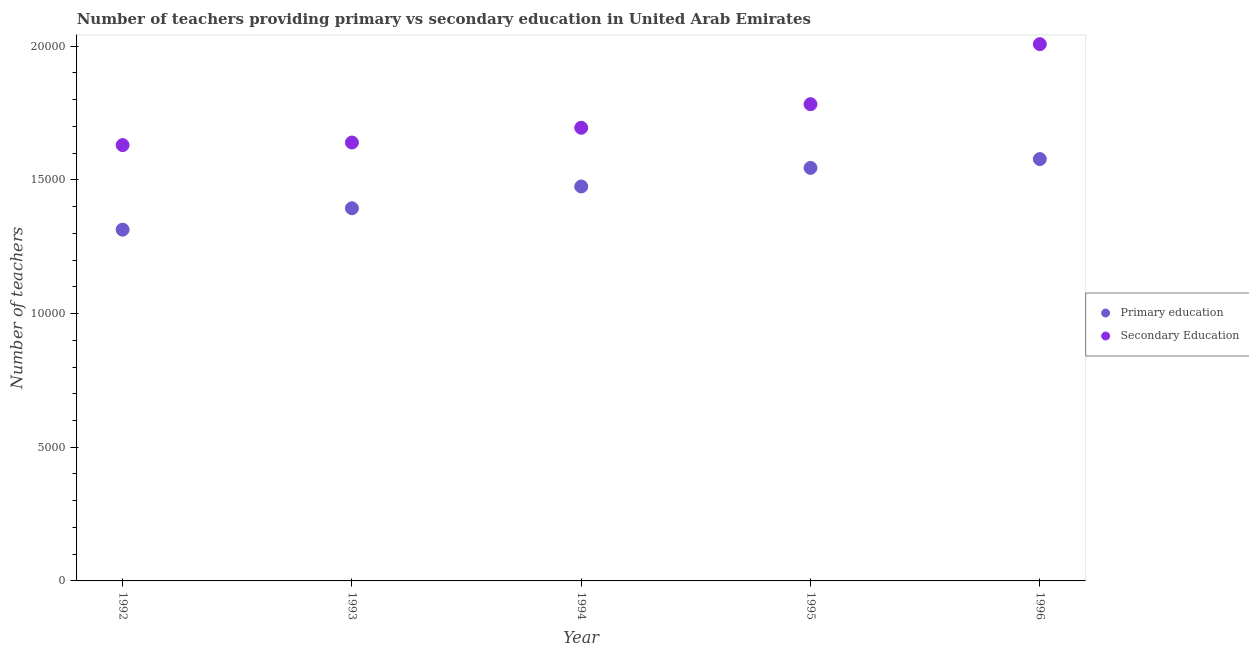What is the number of secondary teachers in 1994?
Your answer should be compact. 1.70e+04. Across all years, what is the maximum number of secondary teachers?
Offer a very short reply. 2.01e+04. Across all years, what is the minimum number of secondary teachers?
Ensure brevity in your answer.  1.63e+04. In which year was the number of primary teachers maximum?
Make the answer very short. 1996. In which year was the number of secondary teachers minimum?
Make the answer very short. 1992. What is the total number of secondary teachers in the graph?
Make the answer very short. 8.76e+04. What is the difference between the number of secondary teachers in 1994 and that in 1995?
Ensure brevity in your answer.  -882. What is the difference between the number of secondary teachers in 1996 and the number of primary teachers in 1995?
Your response must be concise. 4629. What is the average number of secondary teachers per year?
Your answer should be compact. 1.75e+04. In the year 1992, what is the difference between the number of primary teachers and number of secondary teachers?
Your answer should be compact. -3163. What is the ratio of the number of secondary teachers in 1992 to that in 1993?
Ensure brevity in your answer.  0.99. Is the difference between the number of secondary teachers in 1992 and 1996 greater than the difference between the number of primary teachers in 1992 and 1996?
Provide a succinct answer. No. What is the difference between the highest and the second highest number of primary teachers?
Your response must be concise. 330. What is the difference between the highest and the lowest number of secondary teachers?
Your response must be concise. 3776. Does the number of secondary teachers monotonically increase over the years?
Provide a succinct answer. Yes. How many dotlines are there?
Your response must be concise. 2. Does the graph contain any zero values?
Provide a short and direct response. No. Does the graph contain grids?
Ensure brevity in your answer.  No. Where does the legend appear in the graph?
Your answer should be very brief. Center right. How are the legend labels stacked?
Make the answer very short. Vertical. What is the title of the graph?
Provide a short and direct response. Number of teachers providing primary vs secondary education in United Arab Emirates. What is the label or title of the X-axis?
Offer a very short reply. Year. What is the label or title of the Y-axis?
Make the answer very short. Number of teachers. What is the Number of teachers of Primary education in 1992?
Your response must be concise. 1.31e+04. What is the Number of teachers of Secondary Education in 1992?
Provide a succinct answer. 1.63e+04. What is the Number of teachers in Primary education in 1993?
Ensure brevity in your answer.  1.39e+04. What is the Number of teachers of Secondary Education in 1993?
Keep it short and to the point. 1.64e+04. What is the Number of teachers of Primary education in 1994?
Your answer should be very brief. 1.48e+04. What is the Number of teachers of Secondary Education in 1994?
Give a very brief answer. 1.70e+04. What is the Number of teachers of Primary education in 1995?
Keep it short and to the point. 1.54e+04. What is the Number of teachers of Secondary Education in 1995?
Give a very brief answer. 1.78e+04. What is the Number of teachers in Primary education in 1996?
Give a very brief answer. 1.58e+04. What is the Number of teachers of Secondary Education in 1996?
Provide a succinct answer. 2.01e+04. Across all years, what is the maximum Number of teachers of Primary education?
Make the answer very short. 1.58e+04. Across all years, what is the maximum Number of teachers in Secondary Education?
Give a very brief answer. 2.01e+04. Across all years, what is the minimum Number of teachers of Primary education?
Provide a short and direct response. 1.31e+04. Across all years, what is the minimum Number of teachers in Secondary Education?
Ensure brevity in your answer.  1.63e+04. What is the total Number of teachers in Primary education in the graph?
Give a very brief answer. 7.31e+04. What is the total Number of teachers in Secondary Education in the graph?
Your answer should be very brief. 8.76e+04. What is the difference between the Number of teachers of Primary education in 1992 and that in 1993?
Make the answer very short. -801. What is the difference between the Number of teachers of Secondary Education in 1992 and that in 1993?
Your response must be concise. -97. What is the difference between the Number of teachers of Primary education in 1992 and that in 1994?
Offer a very short reply. -1615. What is the difference between the Number of teachers in Secondary Education in 1992 and that in 1994?
Make the answer very short. -648. What is the difference between the Number of teachers in Primary education in 1992 and that in 1995?
Offer a terse response. -2310. What is the difference between the Number of teachers in Secondary Education in 1992 and that in 1995?
Keep it short and to the point. -1530. What is the difference between the Number of teachers of Primary education in 1992 and that in 1996?
Give a very brief answer. -2640. What is the difference between the Number of teachers in Secondary Education in 1992 and that in 1996?
Give a very brief answer. -3776. What is the difference between the Number of teachers in Primary education in 1993 and that in 1994?
Your answer should be compact. -814. What is the difference between the Number of teachers in Secondary Education in 1993 and that in 1994?
Offer a terse response. -551. What is the difference between the Number of teachers of Primary education in 1993 and that in 1995?
Offer a terse response. -1509. What is the difference between the Number of teachers in Secondary Education in 1993 and that in 1995?
Your answer should be compact. -1433. What is the difference between the Number of teachers in Primary education in 1993 and that in 1996?
Provide a short and direct response. -1839. What is the difference between the Number of teachers in Secondary Education in 1993 and that in 1996?
Give a very brief answer. -3679. What is the difference between the Number of teachers of Primary education in 1994 and that in 1995?
Your answer should be very brief. -695. What is the difference between the Number of teachers in Secondary Education in 1994 and that in 1995?
Provide a short and direct response. -882. What is the difference between the Number of teachers in Primary education in 1994 and that in 1996?
Keep it short and to the point. -1025. What is the difference between the Number of teachers in Secondary Education in 1994 and that in 1996?
Your response must be concise. -3128. What is the difference between the Number of teachers of Primary education in 1995 and that in 1996?
Offer a very short reply. -330. What is the difference between the Number of teachers in Secondary Education in 1995 and that in 1996?
Provide a short and direct response. -2246. What is the difference between the Number of teachers in Primary education in 1992 and the Number of teachers in Secondary Education in 1993?
Provide a succinct answer. -3260. What is the difference between the Number of teachers of Primary education in 1992 and the Number of teachers of Secondary Education in 1994?
Give a very brief answer. -3811. What is the difference between the Number of teachers in Primary education in 1992 and the Number of teachers in Secondary Education in 1995?
Give a very brief answer. -4693. What is the difference between the Number of teachers in Primary education in 1992 and the Number of teachers in Secondary Education in 1996?
Provide a succinct answer. -6939. What is the difference between the Number of teachers in Primary education in 1993 and the Number of teachers in Secondary Education in 1994?
Provide a short and direct response. -3010. What is the difference between the Number of teachers in Primary education in 1993 and the Number of teachers in Secondary Education in 1995?
Your answer should be very brief. -3892. What is the difference between the Number of teachers in Primary education in 1993 and the Number of teachers in Secondary Education in 1996?
Provide a short and direct response. -6138. What is the difference between the Number of teachers of Primary education in 1994 and the Number of teachers of Secondary Education in 1995?
Provide a succinct answer. -3078. What is the difference between the Number of teachers of Primary education in 1994 and the Number of teachers of Secondary Education in 1996?
Offer a very short reply. -5324. What is the difference between the Number of teachers in Primary education in 1995 and the Number of teachers in Secondary Education in 1996?
Ensure brevity in your answer.  -4629. What is the average Number of teachers in Primary education per year?
Offer a very short reply. 1.46e+04. What is the average Number of teachers in Secondary Education per year?
Make the answer very short. 1.75e+04. In the year 1992, what is the difference between the Number of teachers of Primary education and Number of teachers of Secondary Education?
Your response must be concise. -3163. In the year 1993, what is the difference between the Number of teachers of Primary education and Number of teachers of Secondary Education?
Your response must be concise. -2459. In the year 1994, what is the difference between the Number of teachers of Primary education and Number of teachers of Secondary Education?
Your answer should be very brief. -2196. In the year 1995, what is the difference between the Number of teachers in Primary education and Number of teachers in Secondary Education?
Make the answer very short. -2383. In the year 1996, what is the difference between the Number of teachers of Primary education and Number of teachers of Secondary Education?
Your answer should be compact. -4299. What is the ratio of the Number of teachers in Primary education in 1992 to that in 1993?
Keep it short and to the point. 0.94. What is the ratio of the Number of teachers of Secondary Education in 1992 to that in 1993?
Your answer should be very brief. 0.99. What is the ratio of the Number of teachers in Primary education in 1992 to that in 1994?
Your response must be concise. 0.89. What is the ratio of the Number of teachers of Secondary Education in 1992 to that in 1994?
Keep it short and to the point. 0.96. What is the ratio of the Number of teachers in Primary education in 1992 to that in 1995?
Make the answer very short. 0.85. What is the ratio of the Number of teachers of Secondary Education in 1992 to that in 1995?
Give a very brief answer. 0.91. What is the ratio of the Number of teachers of Primary education in 1992 to that in 1996?
Your response must be concise. 0.83. What is the ratio of the Number of teachers in Secondary Education in 1992 to that in 1996?
Keep it short and to the point. 0.81. What is the ratio of the Number of teachers in Primary education in 1993 to that in 1994?
Keep it short and to the point. 0.94. What is the ratio of the Number of teachers in Secondary Education in 1993 to that in 1994?
Your response must be concise. 0.97. What is the ratio of the Number of teachers in Primary education in 1993 to that in 1995?
Make the answer very short. 0.9. What is the ratio of the Number of teachers in Secondary Education in 1993 to that in 1995?
Offer a very short reply. 0.92. What is the ratio of the Number of teachers in Primary education in 1993 to that in 1996?
Ensure brevity in your answer.  0.88. What is the ratio of the Number of teachers in Secondary Education in 1993 to that in 1996?
Your answer should be compact. 0.82. What is the ratio of the Number of teachers of Primary education in 1994 to that in 1995?
Give a very brief answer. 0.95. What is the ratio of the Number of teachers of Secondary Education in 1994 to that in 1995?
Offer a terse response. 0.95. What is the ratio of the Number of teachers in Primary education in 1994 to that in 1996?
Offer a very short reply. 0.94. What is the ratio of the Number of teachers in Secondary Education in 1994 to that in 1996?
Ensure brevity in your answer.  0.84. What is the ratio of the Number of teachers of Primary education in 1995 to that in 1996?
Your answer should be compact. 0.98. What is the ratio of the Number of teachers in Secondary Education in 1995 to that in 1996?
Provide a succinct answer. 0.89. What is the difference between the highest and the second highest Number of teachers of Primary education?
Your response must be concise. 330. What is the difference between the highest and the second highest Number of teachers of Secondary Education?
Offer a terse response. 2246. What is the difference between the highest and the lowest Number of teachers in Primary education?
Offer a very short reply. 2640. What is the difference between the highest and the lowest Number of teachers in Secondary Education?
Offer a very short reply. 3776. 